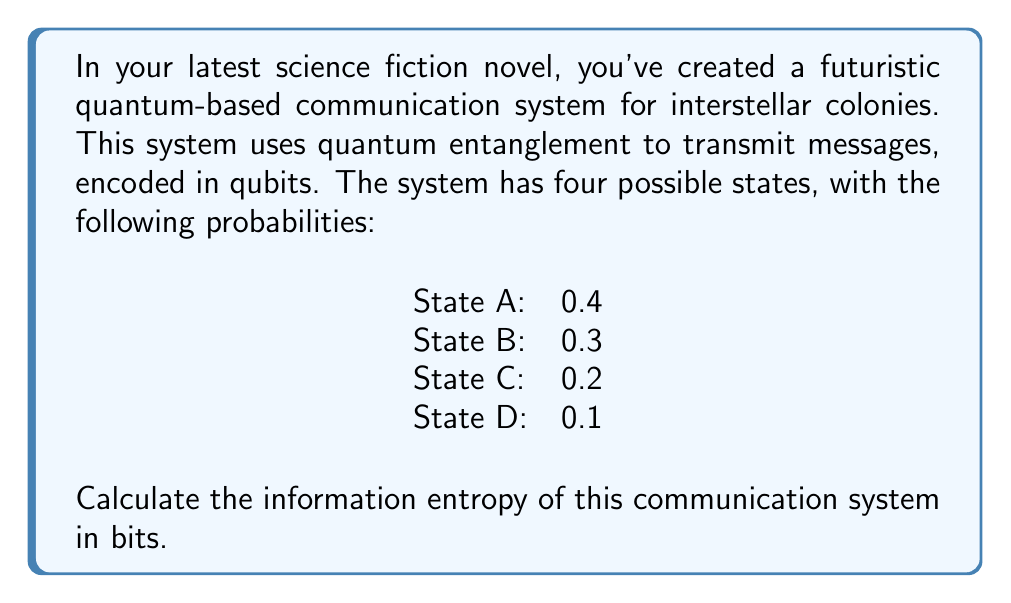Give your solution to this math problem. To calculate the information entropy of this communication system, we'll use the Shannon entropy formula:

$$H = -\sum_{i=1}^n p_i \log_2(p_i)$$

Where:
- $H$ is the entropy in bits
- $p_i$ is the probability of each state
- $n$ is the number of possible states

Let's calculate for each state:

1) State A: $p_1 = 0.4$
   $-0.4 \log_2(0.4) = 0.528321$

2) State B: $p_2 = 0.3$
   $-0.3 \log_2(0.3) = 0.521436$

3) State C: $p_3 = 0.2$
   $-0.2 \log_2(0.2) = 0.464386$

4) State D: $p_4 = 0.1$
   $-0.1 \log_2(0.1) = 0.332193$

Now, we sum these values:

$$H = 0.528321 + 0.521436 + 0.464386 + 0.332193 = 1.846336$$

Therefore, the information entropy of the communication system is approximately 1.846336 bits.
Answer: The information entropy of the futuristic quantum-based communication system is approximately 1.846 bits. 